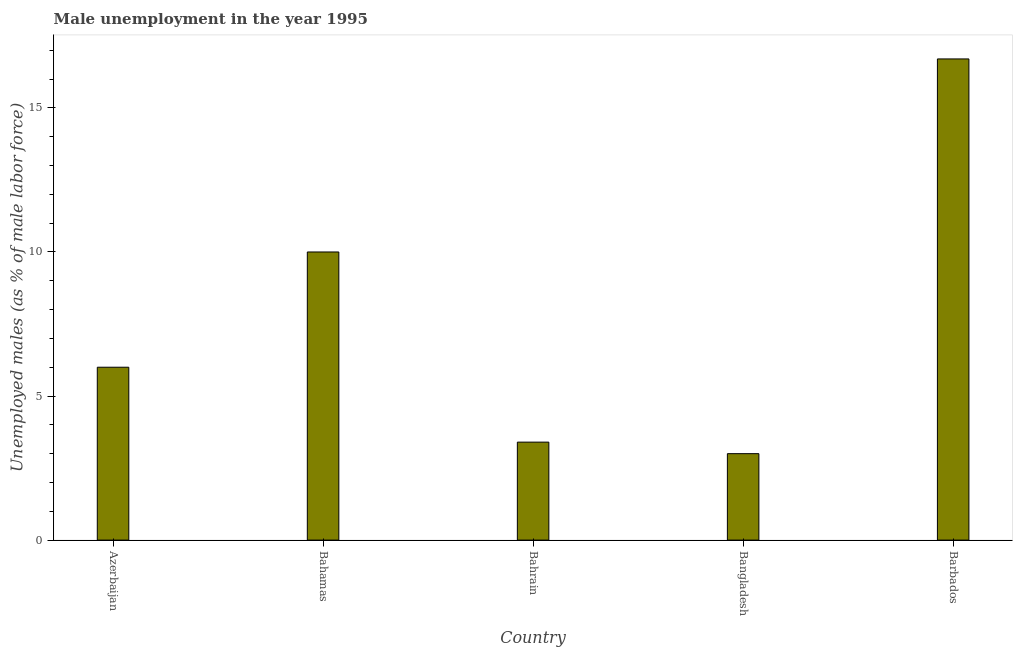Does the graph contain grids?
Give a very brief answer. No. What is the title of the graph?
Make the answer very short. Male unemployment in the year 1995. What is the label or title of the Y-axis?
Offer a terse response. Unemployed males (as % of male labor force). What is the unemployed males population in Barbados?
Provide a succinct answer. 16.7. Across all countries, what is the maximum unemployed males population?
Keep it short and to the point. 16.7. In which country was the unemployed males population maximum?
Offer a very short reply. Barbados. What is the sum of the unemployed males population?
Give a very brief answer. 39.1. What is the difference between the unemployed males population in Bahamas and Bangladesh?
Your response must be concise. 7. What is the average unemployed males population per country?
Your response must be concise. 7.82. What is the ratio of the unemployed males population in Bahamas to that in Bahrain?
Your answer should be compact. 2.94. Is the unemployed males population in Azerbaijan less than that in Bahamas?
Provide a succinct answer. Yes. Is the difference between the unemployed males population in Bahamas and Bangladesh greater than the difference between any two countries?
Keep it short and to the point. No. Is the sum of the unemployed males population in Bangladesh and Barbados greater than the maximum unemployed males population across all countries?
Offer a terse response. Yes. In how many countries, is the unemployed males population greater than the average unemployed males population taken over all countries?
Offer a terse response. 2. Are the values on the major ticks of Y-axis written in scientific E-notation?
Provide a short and direct response. No. What is the Unemployed males (as % of male labor force) of Bahamas?
Offer a terse response. 10. What is the Unemployed males (as % of male labor force) of Bahrain?
Offer a terse response. 3.4. What is the Unemployed males (as % of male labor force) in Barbados?
Keep it short and to the point. 16.7. What is the difference between the Unemployed males (as % of male labor force) in Azerbaijan and Bahamas?
Make the answer very short. -4. What is the difference between the Unemployed males (as % of male labor force) in Azerbaijan and Bangladesh?
Provide a short and direct response. 3. What is the difference between the Unemployed males (as % of male labor force) in Azerbaijan and Barbados?
Your answer should be compact. -10.7. What is the difference between the Unemployed males (as % of male labor force) in Bahamas and Bahrain?
Your answer should be compact. 6.6. What is the difference between the Unemployed males (as % of male labor force) in Bahamas and Bangladesh?
Provide a succinct answer. 7. What is the difference between the Unemployed males (as % of male labor force) in Bahrain and Bangladesh?
Make the answer very short. 0.4. What is the difference between the Unemployed males (as % of male labor force) in Bangladesh and Barbados?
Your answer should be compact. -13.7. What is the ratio of the Unemployed males (as % of male labor force) in Azerbaijan to that in Bahrain?
Your answer should be very brief. 1.76. What is the ratio of the Unemployed males (as % of male labor force) in Azerbaijan to that in Barbados?
Your answer should be very brief. 0.36. What is the ratio of the Unemployed males (as % of male labor force) in Bahamas to that in Bahrain?
Offer a very short reply. 2.94. What is the ratio of the Unemployed males (as % of male labor force) in Bahamas to that in Bangladesh?
Your response must be concise. 3.33. What is the ratio of the Unemployed males (as % of male labor force) in Bahamas to that in Barbados?
Keep it short and to the point. 0.6. What is the ratio of the Unemployed males (as % of male labor force) in Bahrain to that in Bangladesh?
Your answer should be compact. 1.13. What is the ratio of the Unemployed males (as % of male labor force) in Bahrain to that in Barbados?
Ensure brevity in your answer.  0.2. What is the ratio of the Unemployed males (as % of male labor force) in Bangladesh to that in Barbados?
Provide a short and direct response. 0.18. 